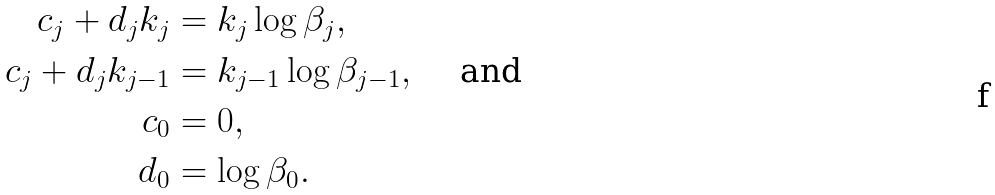<formula> <loc_0><loc_0><loc_500><loc_500>c _ { j } + d _ { j } k _ { j } & = k _ { j } \log \beta _ { j } , \\ c _ { j } + d _ { j } k _ { j - 1 } & = k _ { j - 1 } \log \beta _ { j - 1 } , \quad \text { and } \\ c _ { 0 } & = 0 , \\ d _ { 0 } & = \log \beta _ { 0 } .</formula> 